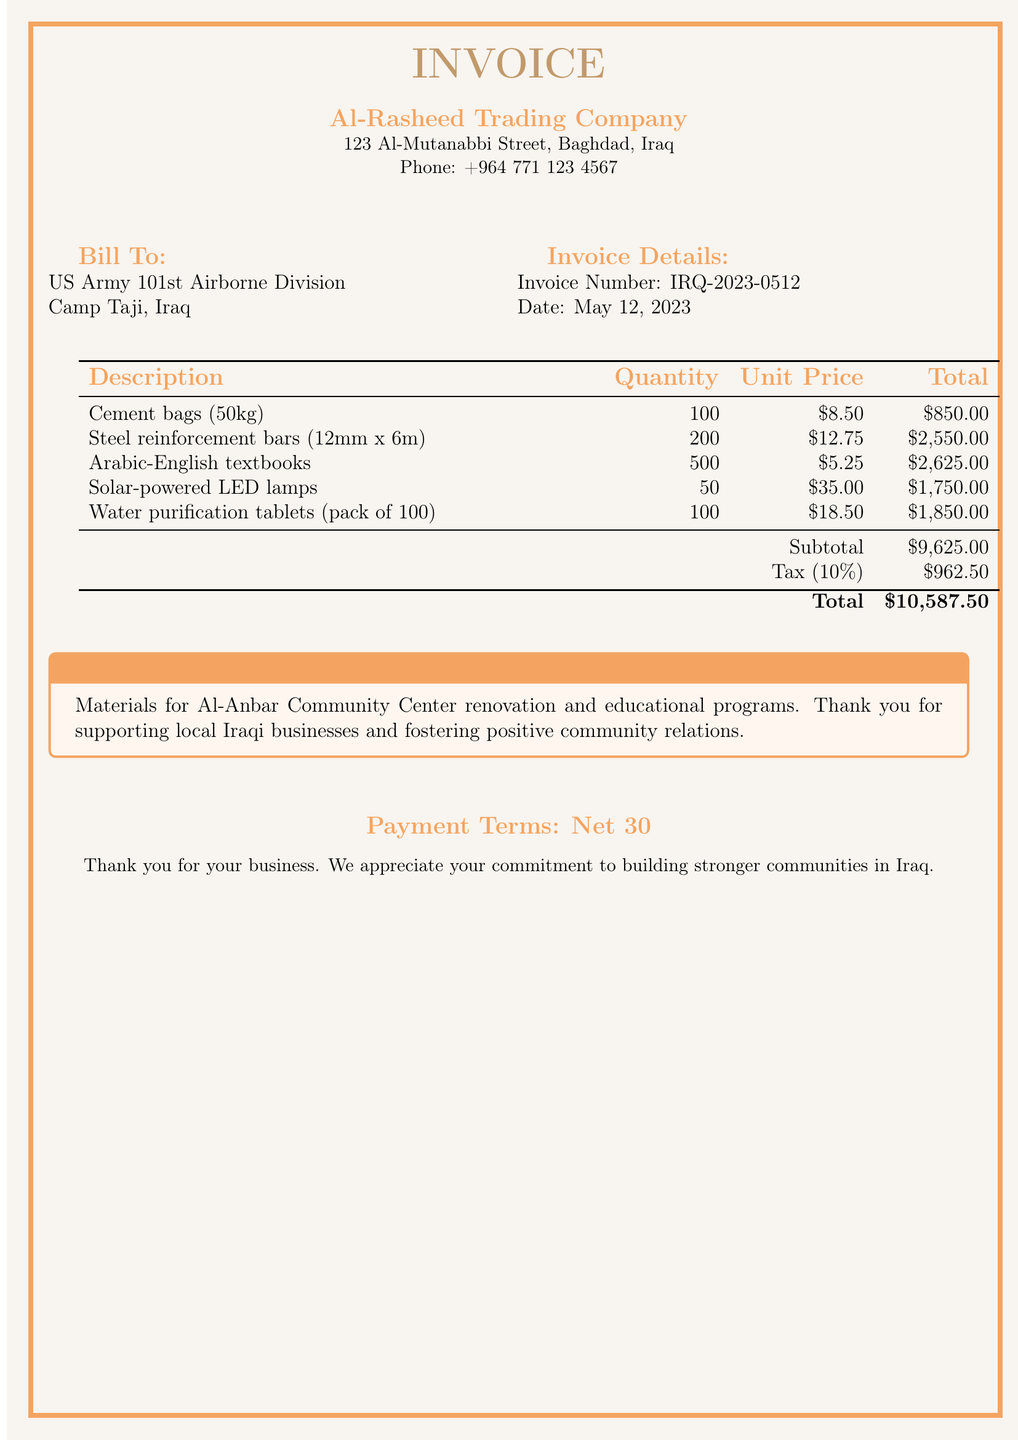What is the invoice number? The invoice number is specified in the document under the invoice details section.
Answer: IRQ-2023-0512 Who is the billing company? The billing company is mentioned at the top of the invoice.
Answer: Al-Rasheed Trading Company What is the total amount due? The total amount due is calculated at the bottom of the invoice.
Answer: $10,587.50 How many cement bags are listed? The quantity of cement bags can be found in the description of materials.
Answer: 100 What percentage is the tax applied to the subtotal? The tax percentage is provided in the invoice table under tax details.
Answer: 10% Which type of textbooks is included in the invoice? The type of textbooks is mentioned in the list of materials.
Answer: Arabic-English textbooks What is the payment term specified in the document? The payment term is stated in the notes at the bottom of the invoice.
Answer: Net 30 What is the subtotal amount before tax? The subtotal amount is indicated in the invoice summary table.
Answer: $9,625.00 What community project is being supported through this invoice? The community project being supported is mentioned in the notes section of the document.
Answer: Al-Anbar Community Center renovation 